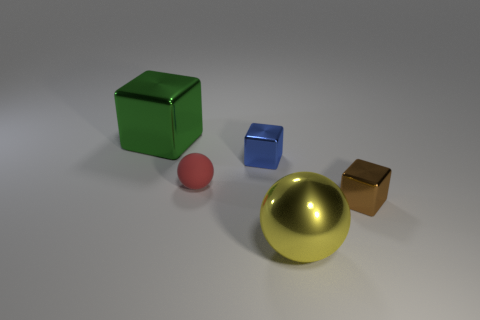Add 4 tiny yellow metallic objects. How many objects exist? 9 Subtract all tiny blocks. How many blocks are left? 1 Add 3 brown metallic objects. How many brown metallic objects exist? 4 Subtract all red spheres. How many spheres are left? 1 Subtract 1 blue blocks. How many objects are left? 4 Subtract all spheres. How many objects are left? 3 Subtract 1 balls. How many balls are left? 1 Subtract all gray cubes. Subtract all brown cylinders. How many cubes are left? 3 Subtract all blue spheres. How many blue blocks are left? 1 Subtract all small rubber objects. Subtract all large things. How many objects are left? 2 